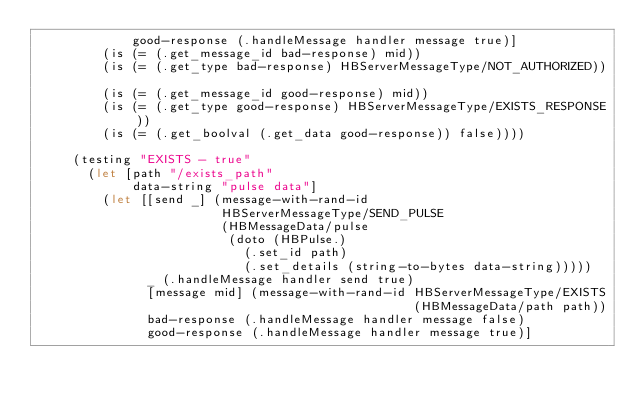Convert code to text. <code><loc_0><loc_0><loc_500><loc_500><_Clojure_>             good-response (.handleMessage handler message true)]
         (is (= (.get_message_id bad-response) mid))
         (is (= (.get_type bad-response) HBServerMessageType/NOT_AUTHORIZED))

         (is (= (.get_message_id good-response) mid))
         (is (= (.get_type good-response) HBServerMessageType/EXISTS_RESPONSE))
         (is (= (.get_boolval (.get_data good-response)) false))))

     (testing "EXISTS - true"
       (let [path "/exists_path"
             data-string "pulse data"]
         (let [[send _] (message-with-rand-id
                         HBServerMessageType/SEND_PULSE
                         (HBMessageData/pulse
                          (doto (HBPulse.)
                            (.set_id path)
                            (.set_details (string-to-bytes data-string)))))
               _ (.handleMessage handler send true)
               [message mid] (message-with-rand-id HBServerMessageType/EXISTS
                                                   (HBMessageData/path path))
               bad-response (.handleMessage handler message false)
               good-response (.handleMessage handler message true)]</code> 